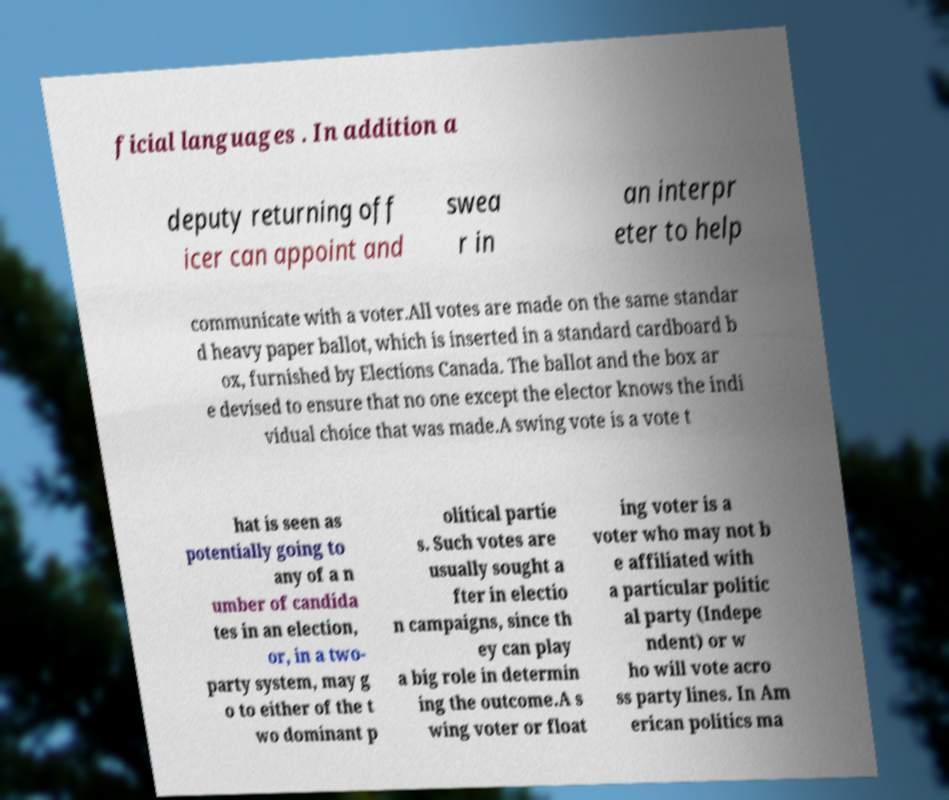Can you read and provide the text displayed in the image?This photo seems to have some interesting text. Can you extract and type it out for me? ficial languages . In addition a deputy returning off icer can appoint and swea r in an interpr eter to help communicate with a voter.All votes are made on the same standar d heavy paper ballot, which is inserted in a standard cardboard b ox, furnished by Elections Canada. The ballot and the box ar e devised to ensure that no one except the elector knows the indi vidual choice that was made.A swing vote is a vote t hat is seen as potentially going to any of a n umber of candida tes in an election, or, in a two- party system, may g o to either of the t wo dominant p olitical partie s. Such votes are usually sought a fter in electio n campaigns, since th ey can play a big role in determin ing the outcome.A s wing voter or float ing voter is a voter who may not b e affiliated with a particular politic al party (Indepe ndent) or w ho will vote acro ss party lines. In Am erican politics ma 